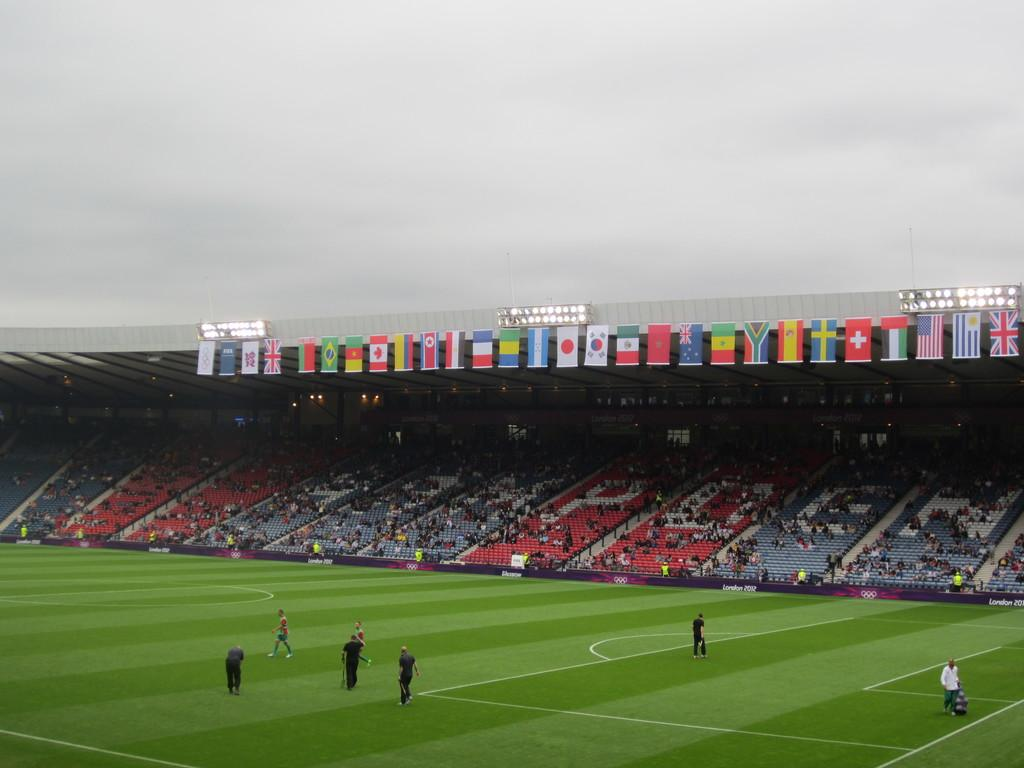What type of structure is shown in the image? There is a stadium in the image. What are people doing inside the stadium? People are standing and walking on the ground inside the stadium. Who is present in the stadium besides the people on the ground? There is an audience in the stadium. What decorative elements can be seen in the stadium? Flags are present in the stadium. What can be used to illuminate the stadium at night? Lights are visible in the stadium. What is the weather like in the image? The sky is cloudy in the image. Can you see any visitors wearing masks in the image? There is no mention of visitors wearing masks in the image; the focus is on the stadium, people, and other elements present. What type of farming equipment can be seen in the image? There is no farming equipment, such as a plough, present in the image. 